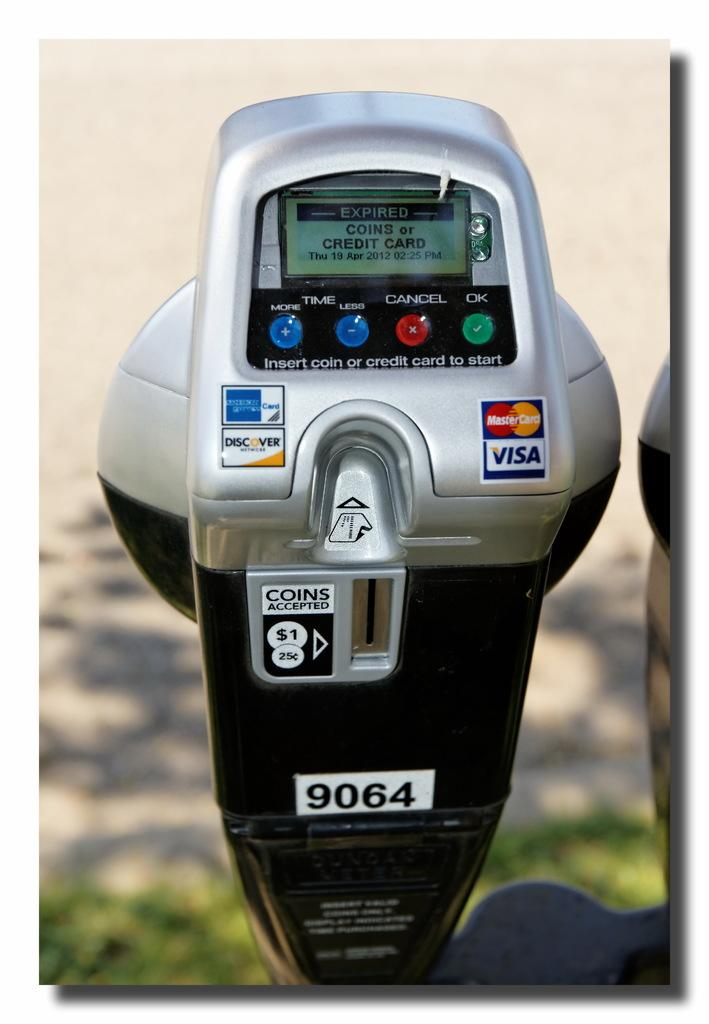What object can be seen in the image that is related to parking? There is a parking meter in the image. What is your opinion on the shade of the parking meter in the image? The provided facts do not include any information about the shade or color of the parking meter, so it is not possible to answer that question. 